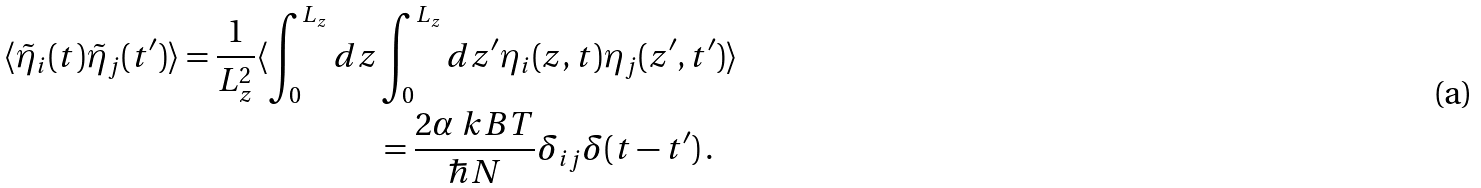<formula> <loc_0><loc_0><loc_500><loc_500>\langle \tilde { \eta } _ { i } ( t ) \tilde { \eta } _ { j } ( t ^ { \prime } ) \rangle = \frac { 1 } { L _ { z } ^ { 2 } } \langle \int _ { 0 } ^ { L _ { z } } d z & \int _ { 0 } ^ { L _ { z } } d z ^ { \prime } \eta _ { i } ( z , t ) \eta _ { j } ( z ^ { \prime } , t ^ { \prime } ) \rangle \\ & = \frac { 2 \alpha \ k B T } { \hbar { N } } \delta _ { i j } \delta ( t - t ^ { \prime } ) \, .</formula> 